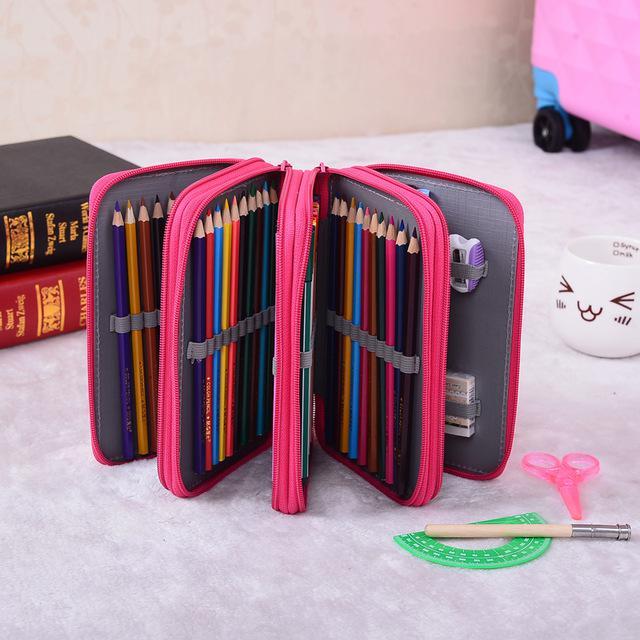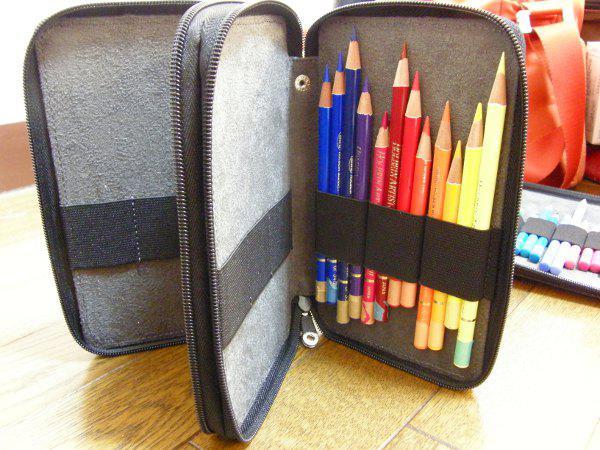The first image is the image on the left, the second image is the image on the right. Given the left and right images, does the statement "Both images feature pencils strapped inside a case." hold true? Answer yes or no. Yes. 